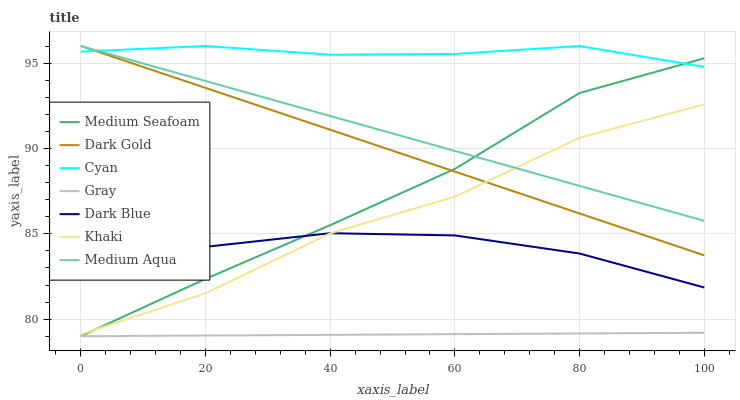Does Gray have the minimum area under the curve?
Answer yes or no. Yes. Does Cyan have the maximum area under the curve?
Answer yes or no. Yes. Does Khaki have the minimum area under the curve?
Answer yes or no. No. Does Khaki have the maximum area under the curve?
Answer yes or no. No. Is Medium Aqua the smoothest?
Answer yes or no. Yes. Is Khaki the roughest?
Answer yes or no. Yes. Is Dark Gold the smoothest?
Answer yes or no. No. Is Dark Gold the roughest?
Answer yes or no. No. Does Gray have the lowest value?
Answer yes or no. Yes. Does Khaki have the lowest value?
Answer yes or no. No. Does Cyan have the highest value?
Answer yes or no. Yes. Does Khaki have the highest value?
Answer yes or no. No. Is Gray less than Dark Blue?
Answer yes or no. Yes. Is Medium Aqua greater than Dark Blue?
Answer yes or no. Yes. Does Medium Seafoam intersect Khaki?
Answer yes or no. Yes. Is Medium Seafoam less than Khaki?
Answer yes or no. No. Is Medium Seafoam greater than Khaki?
Answer yes or no. No. Does Gray intersect Dark Blue?
Answer yes or no. No. 